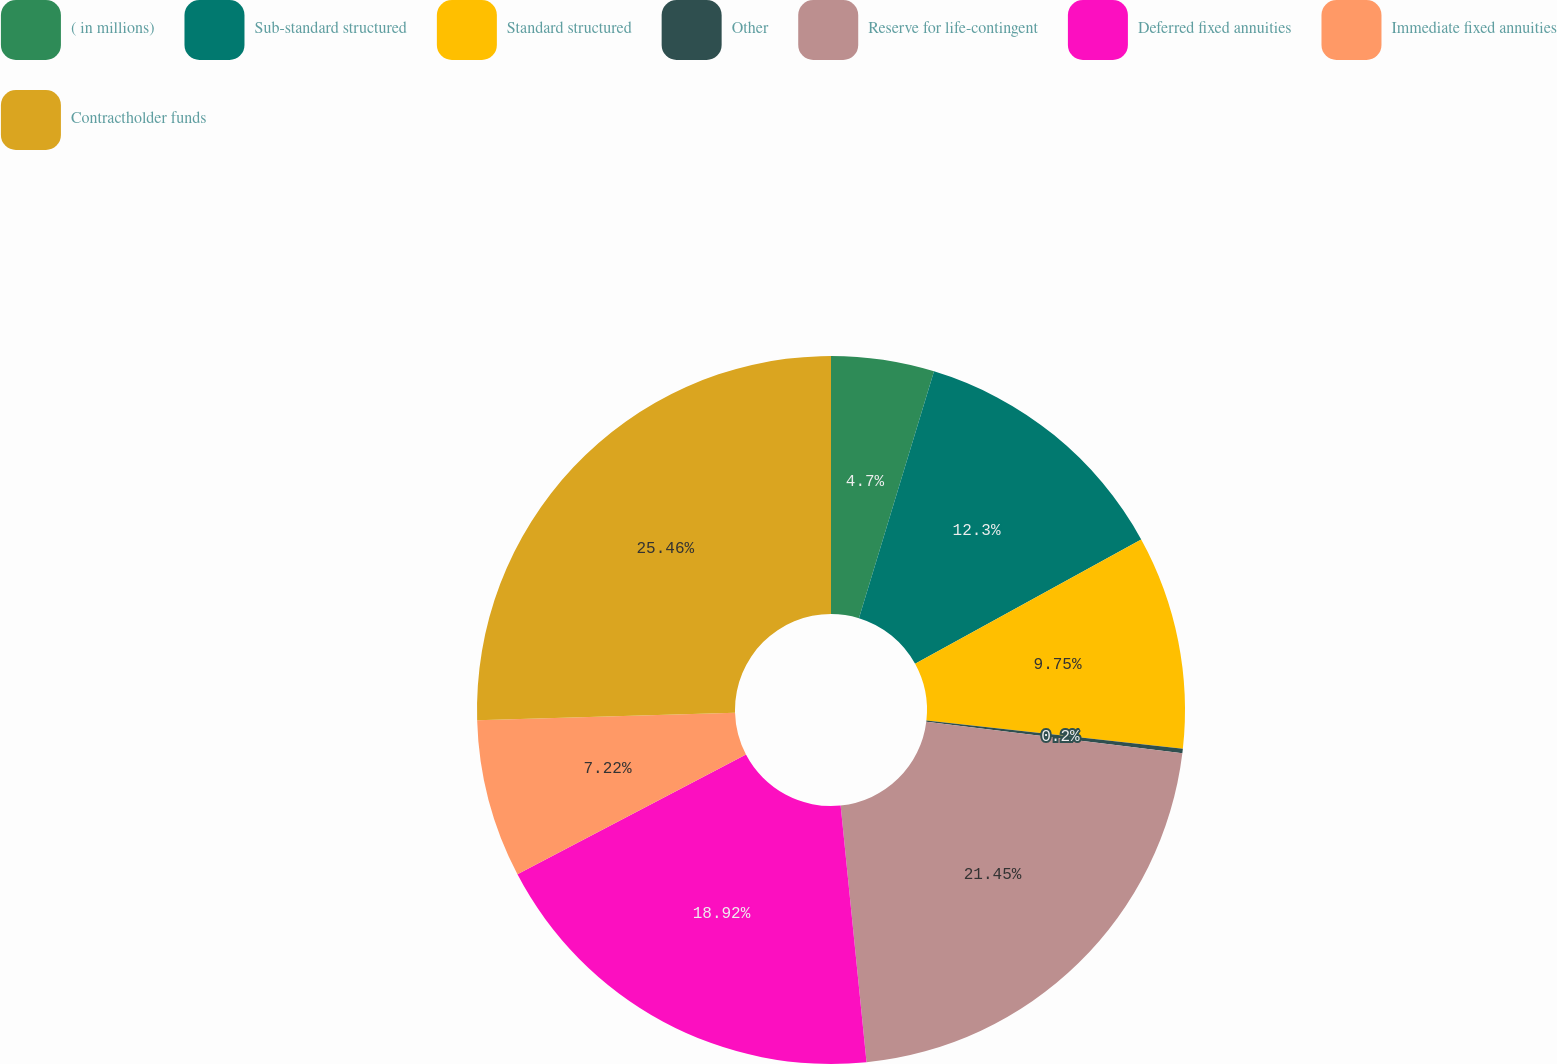Convert chart. <chart><loc_0><loc_0><loc_500><loc_500><pie_chart><fcel>( in millions)<fcel>Sub-standard structured<fcel>Standard structured<fcel>Other<fcel>Reserve for life-contingent<fcel>Deferred fixed annuities<fcel>Immediate fixed annuities<fcel>Contractholder funds<nl><fcel>4.7%<fcel>12.3%<fcel>9.75%<fcel>0.2%<fcel>21.45%<fcel>18.92%<fcel>7.22%<fcel>25.46%<nl></chart> 